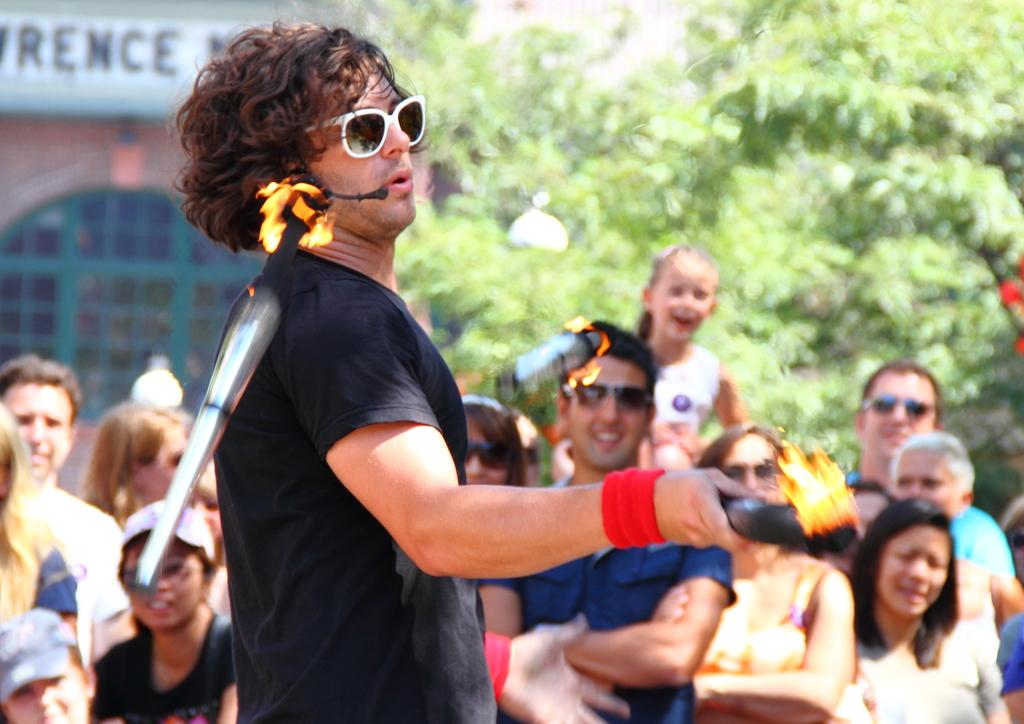What is the person in the image doing? The person is playing with fire lamps in the image. How is the person interacting with the fire lamps? The person is juggling the fire lamps. Are there any other people visible in the image? Yes, there are a few persons standing in the image. What can be seen in the background of the image? There are trees and a building in the background of the image. What type of scarf is the person wearing while juggling the fire lamps? There is no scarf visible on the person in the image. What is the value of the fire lamps being juggled in the image? The value of the fire lamps cannot be determined from the image alone. 